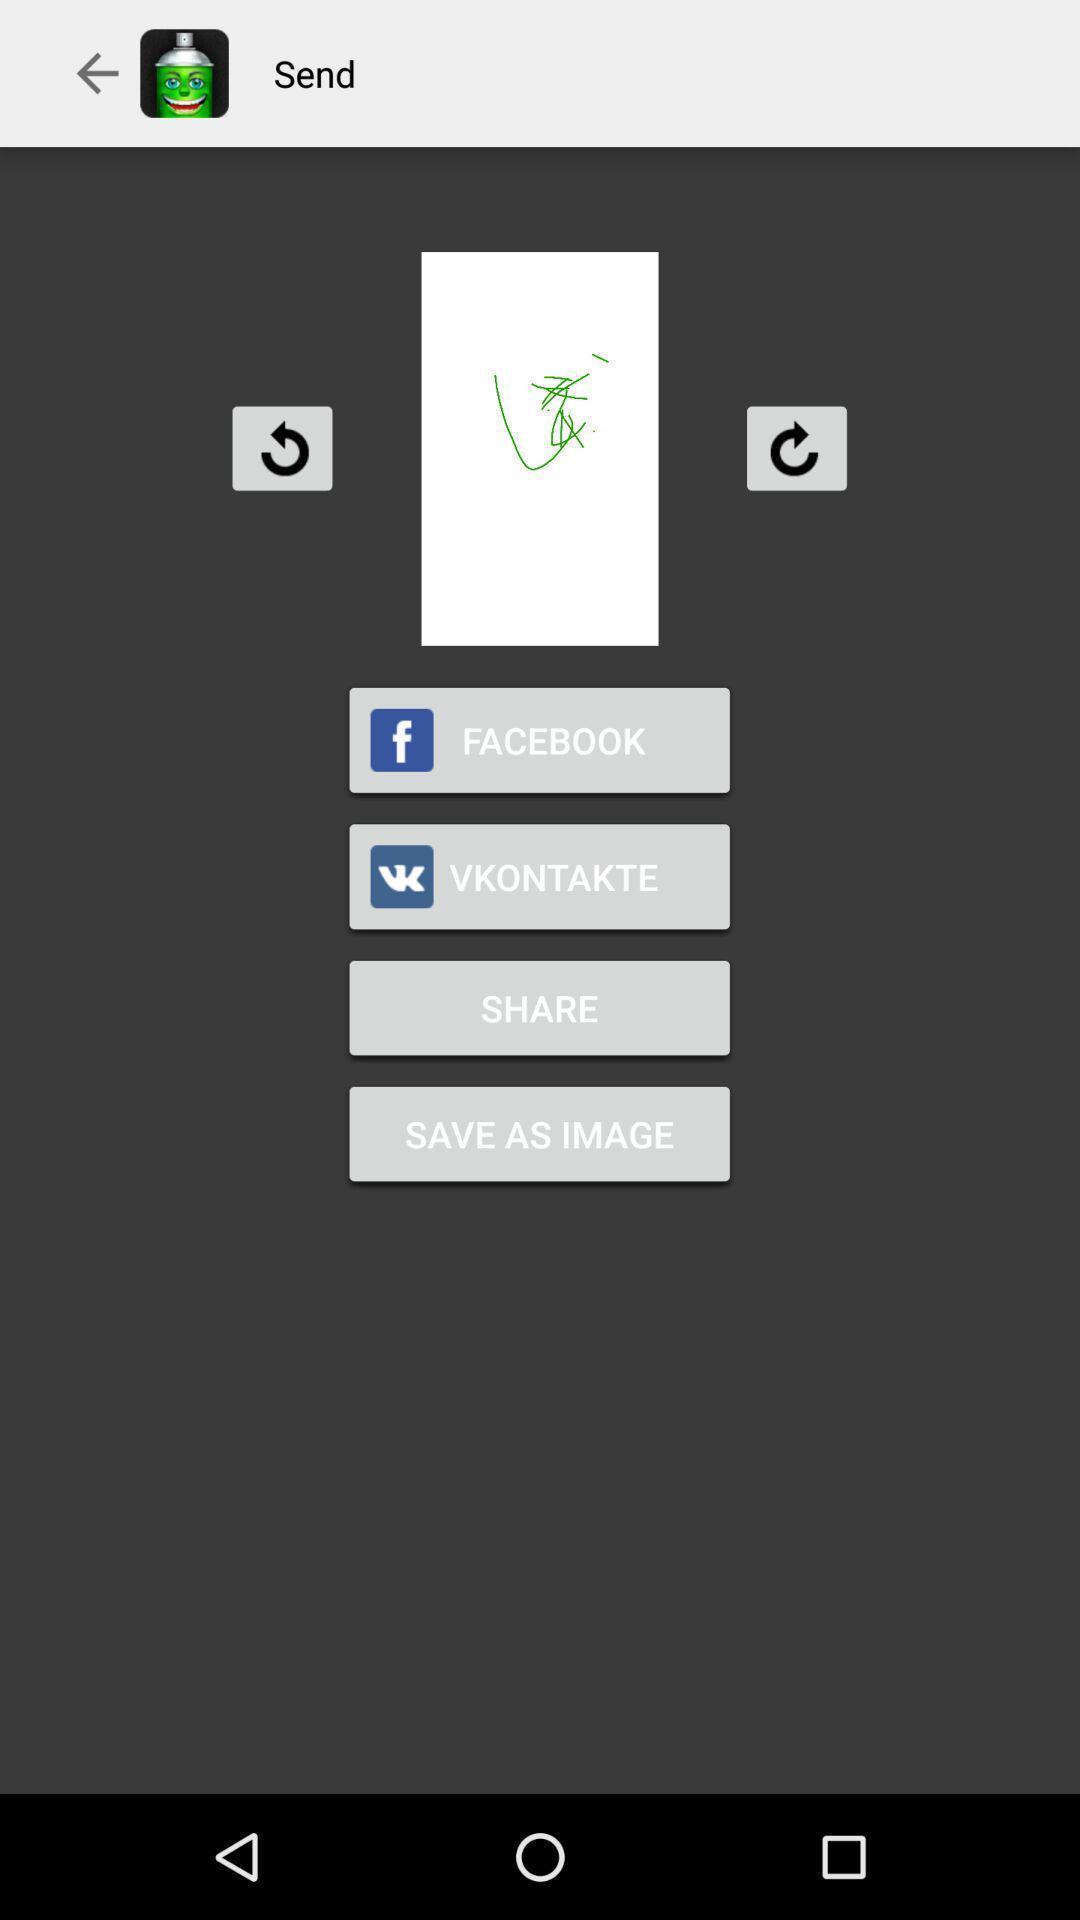Tell me what you see in this picture. Sign in page of different social media apps. 